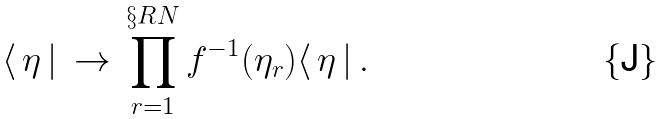<formula> <loc_0><loc_0><loc_500><loc_500>\langle \, \eta \, | \, \rightarrow \, \prod _ { r = 1 } ^ { \S R N } f ^ { - 1 } ( \eta _ { r } ) \langle \, \eta \, | \, .</formula> 